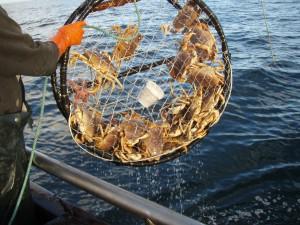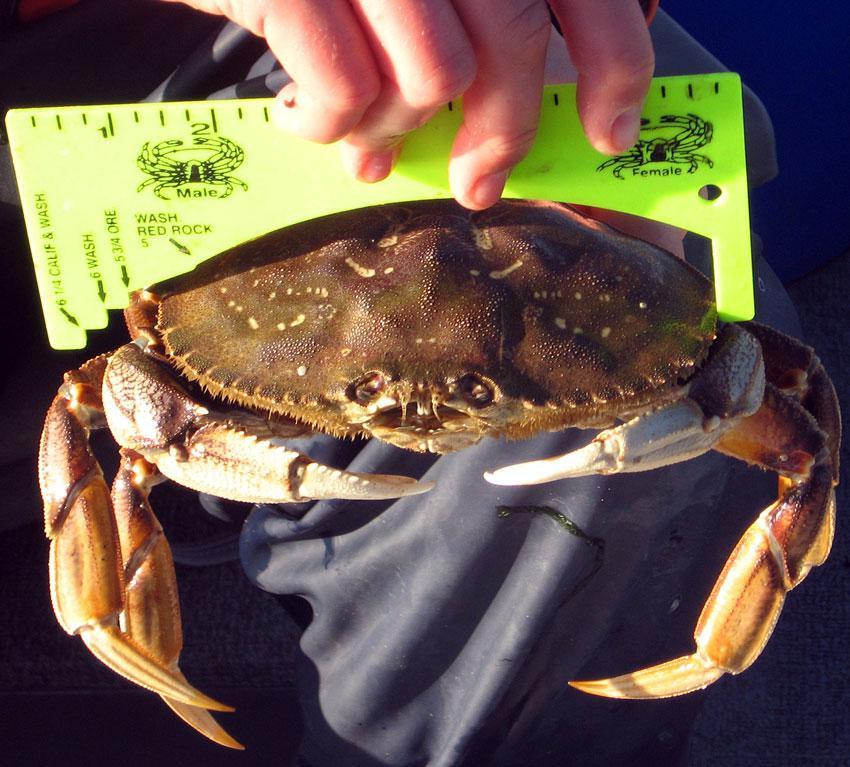The first image is the image on the left, the second image is the image on the right. For the images displayed, is the sentence "In at least one image there is a round crab trap that is holding at least 15 crab while being held by a person in a boat." factually correct? Answer yes or no. Yes. The first image is the image on the left, the second image is the image on the right. Considering the images on both sides, is "There are crabs inside a cage." valid? Answer yes or no. Yes. 